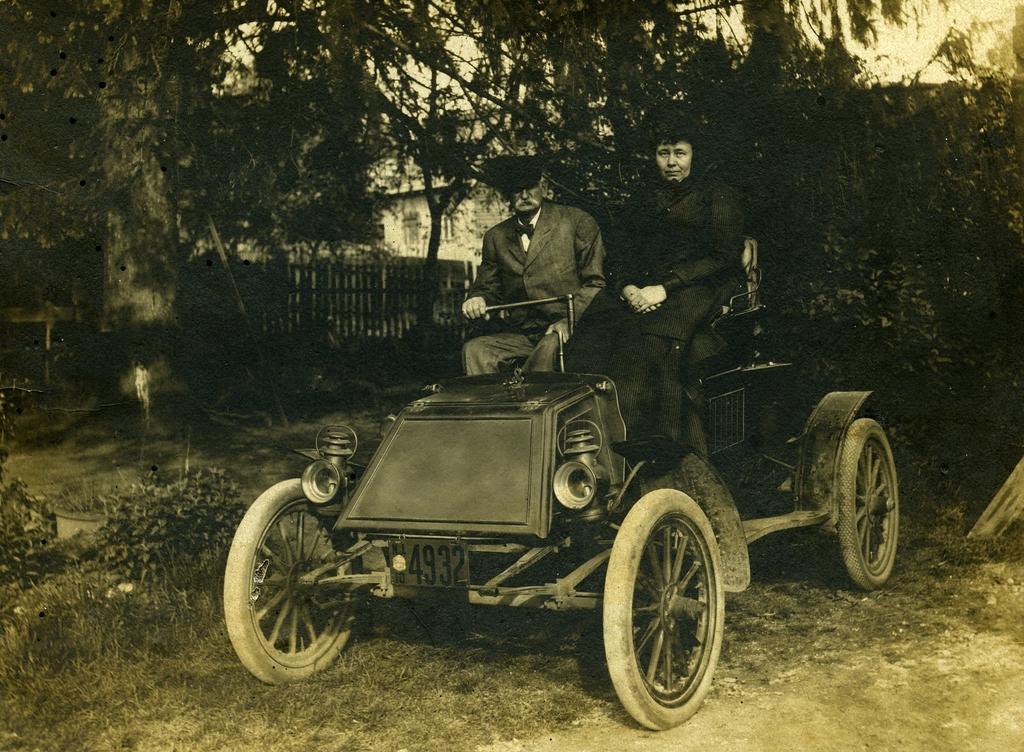Could you give a brief overview of what you see in this image? In this picture two people are sitting on a old car which has a number 4932,the picture is clicked inside a lawn. In the background there are trees and buildings. 